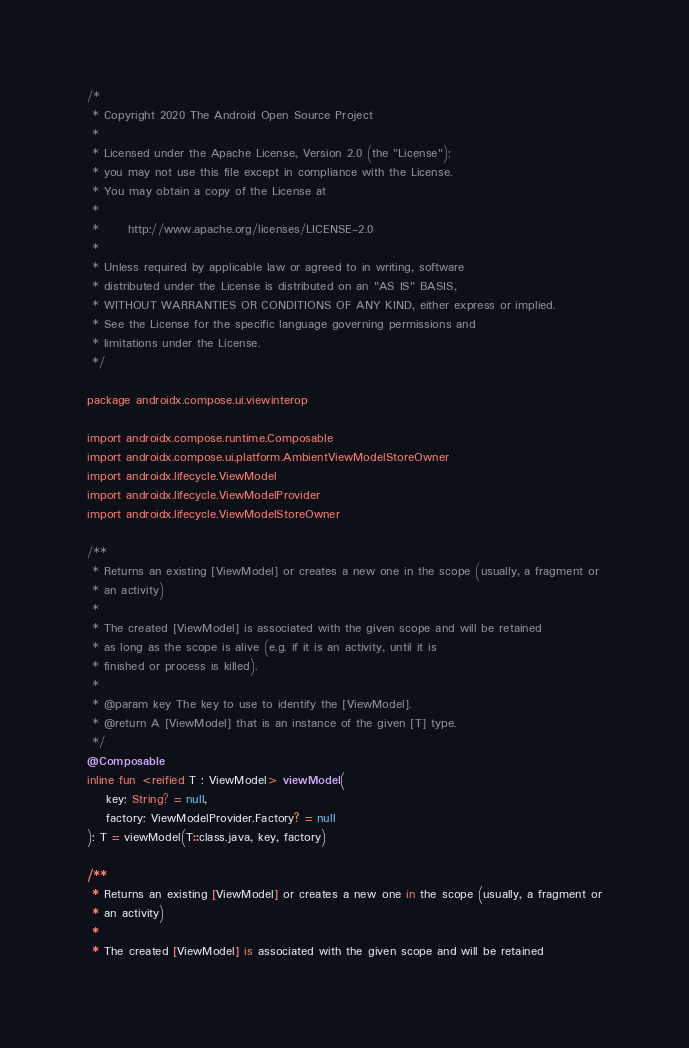<code> <loc_0><loc_0><loc_500><loc_500><_Kotlin_>/*
 * Copyright 2020 The Android Open Source Project
 *
 * Licensed under the Apache License, Version 2.0 (the "License");
 * you may not use this file except in compliance with the License.
 * You may obtain a copy of the License at
 *
 *      http://www.apache.org/licenses/LICENSE-2.0
 *
 * Unless required by applicable law or agreed to in writing, software
 * distributed under the License is distributed on an "AS IS" BASIS,
 * WITHOUT WARRANTIES OR CONDITIONS OF ANY KIND, either express or implied.
 * See the License for the specific language governing permissions and
 * limitations under the License.
 */

package androidx.compose.ui.viewinterop

import androidx.compose.runtime.Composable
import androidx.compose.ui.platform.AmbientViewModelStoreOwner
import androidx.lifecycle.ViewModel
import androidx.lifecycle.ViewModelProvider
import androidx.lifecycle.ViewModelStoreOwner

/**
 * Returns an existing [ViewModel] or creates a new one in the scope (usually, a fragment or
 * an activity)
 *
 * The created [ViewModel] is associated with the given scope and will be retained
 * as long as the scope is alive (e.g. if it is an activity, until it is
 * finished or process is killed).
 *
 * @param key The key to use to identify the [ViewModel].
 * @return A [ViewModel] that is an instance of the given [T] type.
 */
@Composable
inline fun <reified T : ViewModel> viewModel(
    key: String? = null,
    factory: ViewModelProvider.Factory? = null
): T = viewModel(T::class.java, key, factory)

/**
 * Returns an existing [ViewModel] or creates a new one in the scope (usually, a fragment or
 * an activity)
 *
 * The created [ViewModel] is associated with the given scope and will be retained</code> 